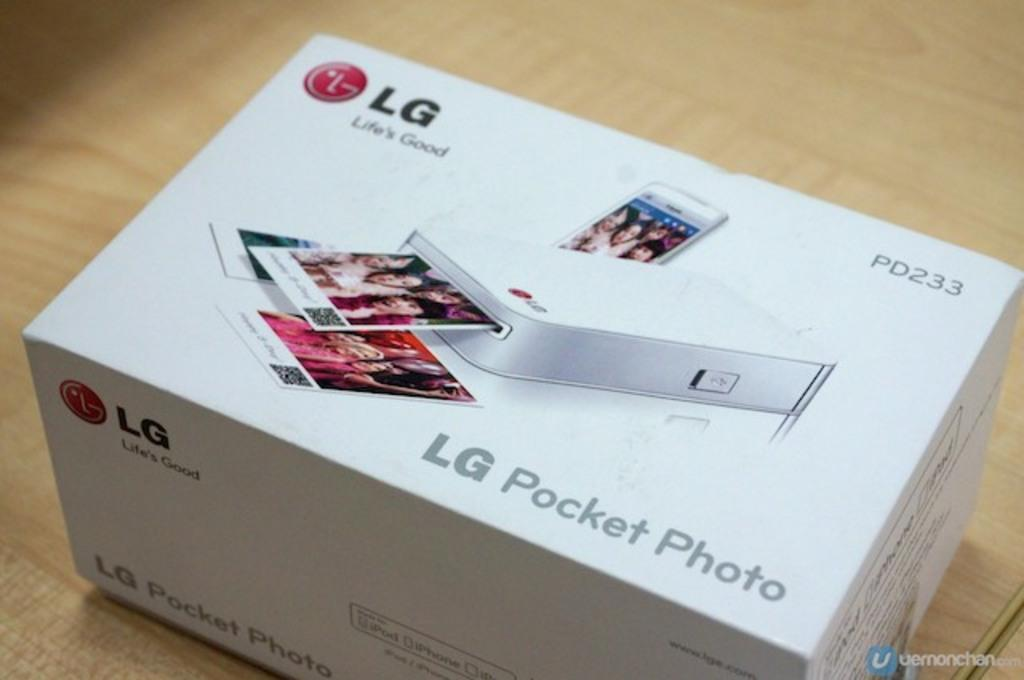Provide a one-sentence caption for the provided image. an LG pocket photo dispenser PD233 in a new box. 